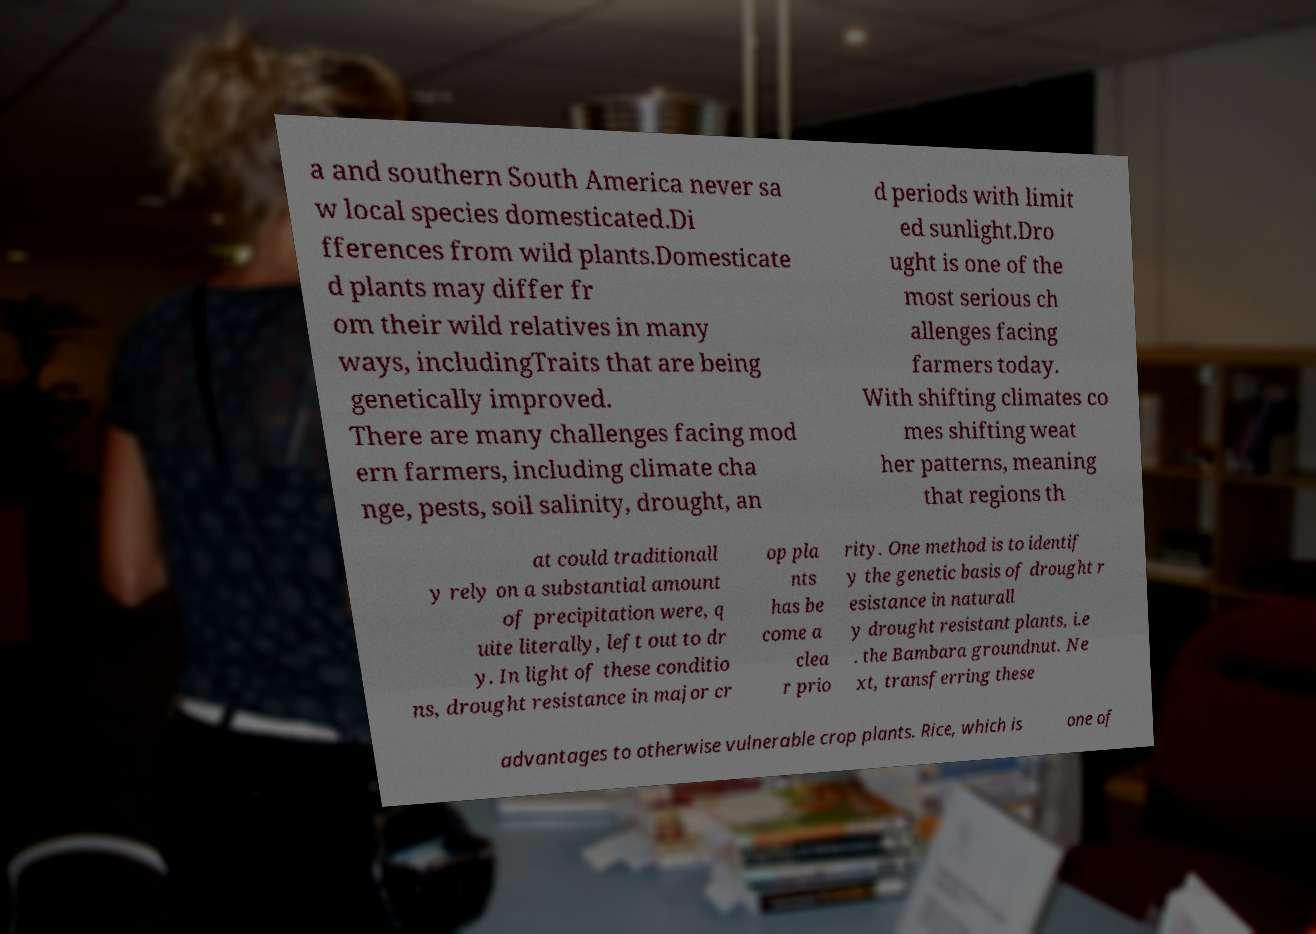Please identify and transcribe the text found in this image. a and southern South America never sa w local species domesticated.Di fferences from wild plants.Domesticate d plants may differ fr om their wild relatives in many ways, includingTraits that are being genetically improved. There are many challenges facing mod ern farmers, including climate cha nge, pests, soil salinity, drought, an d periods with limit ed sunlight.Dro ught is one of the most serious ch allenges facing farmers today. With shifting climates co mes shifting weat her patterns, meaning that regions th at could traditionall y rely on a substantial amount of precipitation were, q uite literally, left out to dr y. In light of these conditio ns, drought resistance in major cr op pla nts has be come a clea r prio rity. One method is to identif y the genetic basis of drought r esistance in naturall y drought resistant plants, i.e . the Bambara groundnut. Ne xt, transferring these advantages to otherwise vulnerable crop plants. Rice, which is one of 